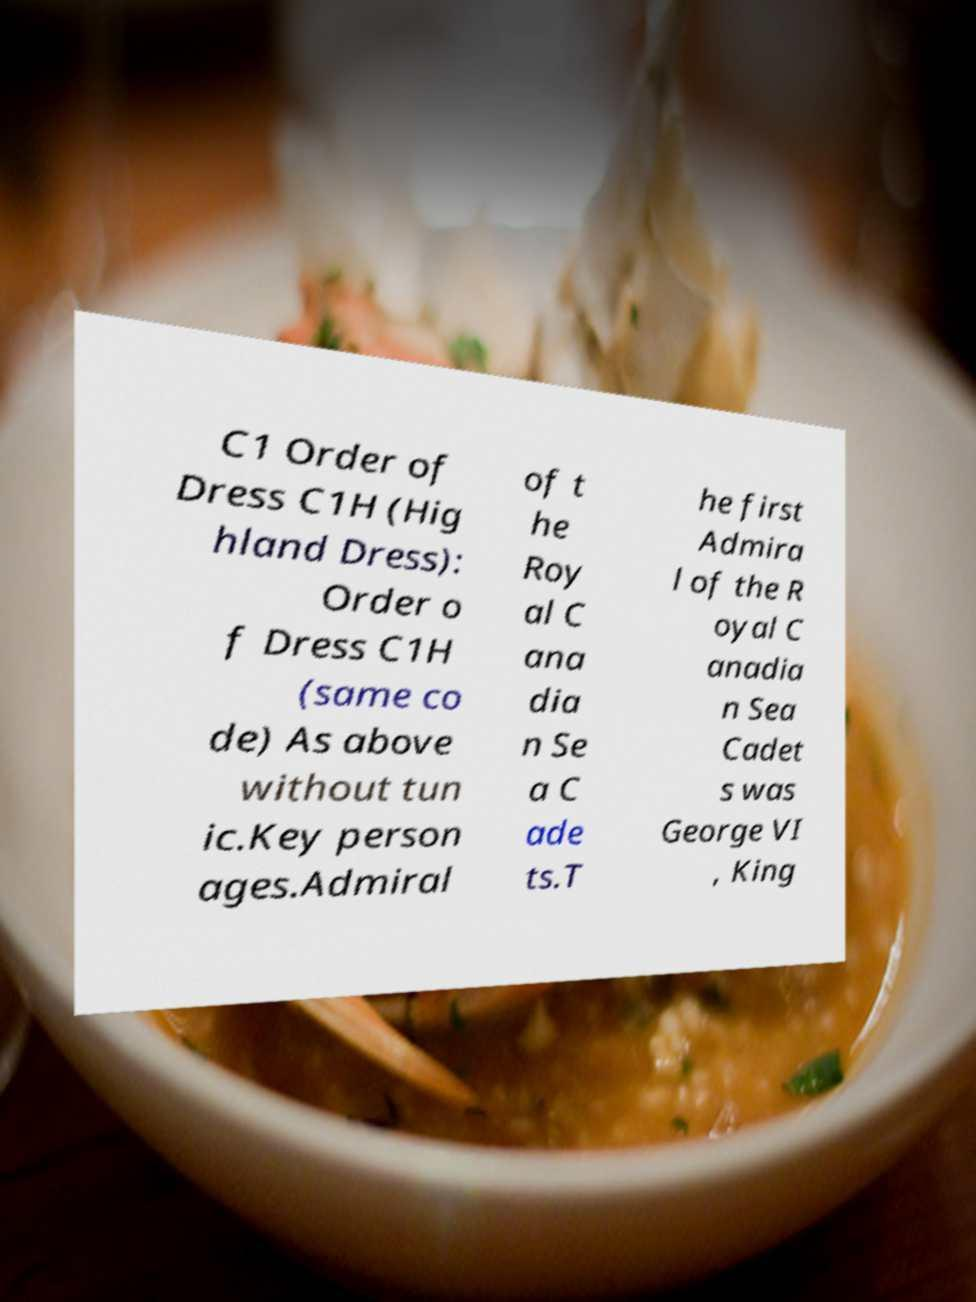Can you read and provide the text displayed in the image?This photo seems to have some interesting text. Can you extract and type it out for me? C1 Order of Dress C1H (Hig hland Dress): Order o f Dress C1H (same co de) As above without tun ic.Key person ages.Admiral of t he Roy al C ana dia n Se a C ade ts.T he first Admira l of the R oyal C anadia n Sea Cadet s was George VI , King 